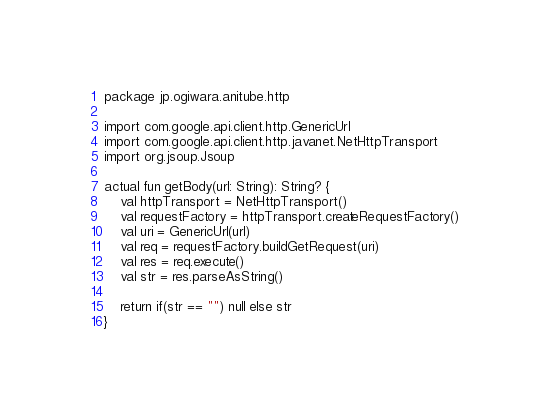Convert code to text. <code><loc_0><loc_0><loc_500><loc_500><_Kotlin_>package jp.ogiwara.anitube.http

import com.google.api.client.http.GenericUrl
import com.google.api.client.http.javanet.NetHttpTransport
import org.jsoup.Jsoup

actual fun getBody(url: String): String? {
    val httpTransport = NetHttpTransport()
    val requestFactory = httpTransport.createRequestFactory()
    val uri = GenericUrl(url)
    val req = requestFactory.buildGetRequest(uri)
    val res = req.execute()
    val str = res.parseAsString()

    return if(str == "") null else str
}</code> 